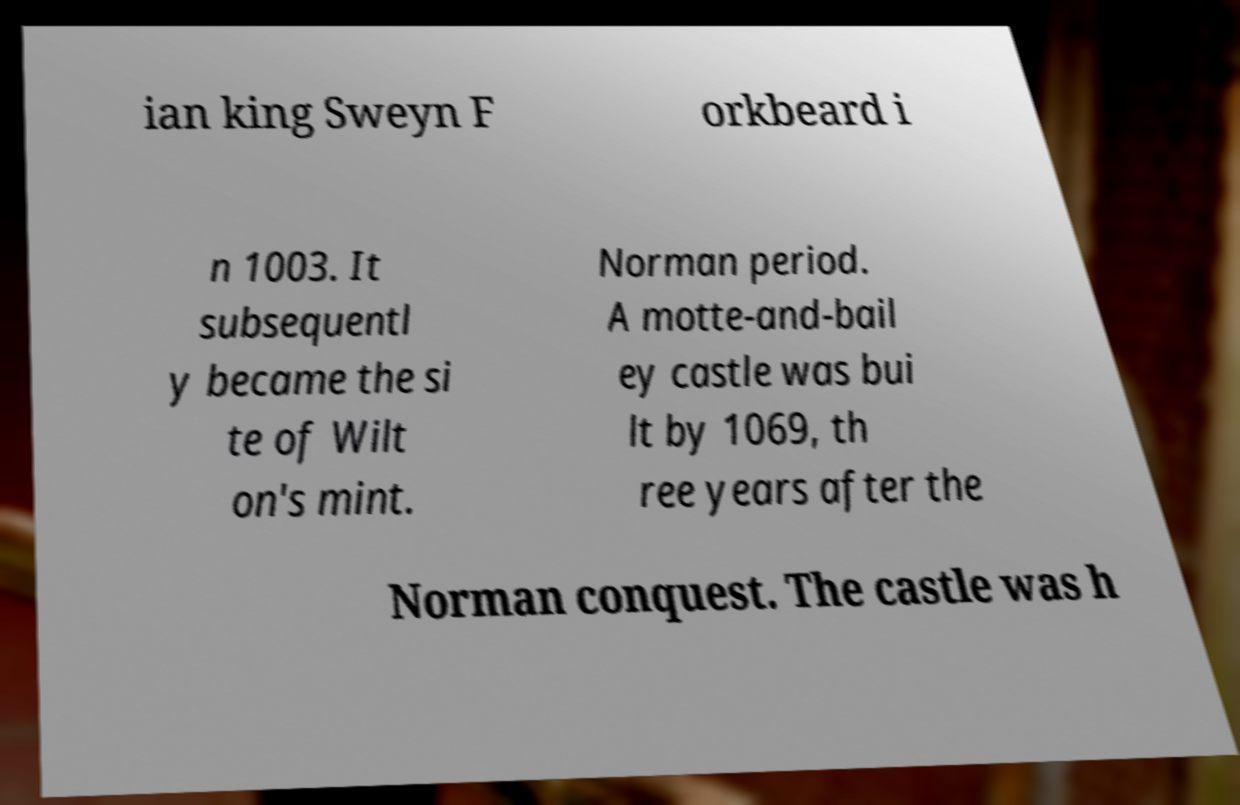What messages or text are displayed in this image? I need them in a readable, typed format. ian king Sweyn F orkbeard i n 1003. It subsequentl y became the si te of Wilt on's mint. Norman period. A motte-and-bail ey castle was bui lt by 1069, th ree years after the Norman conquest. The castle was h 